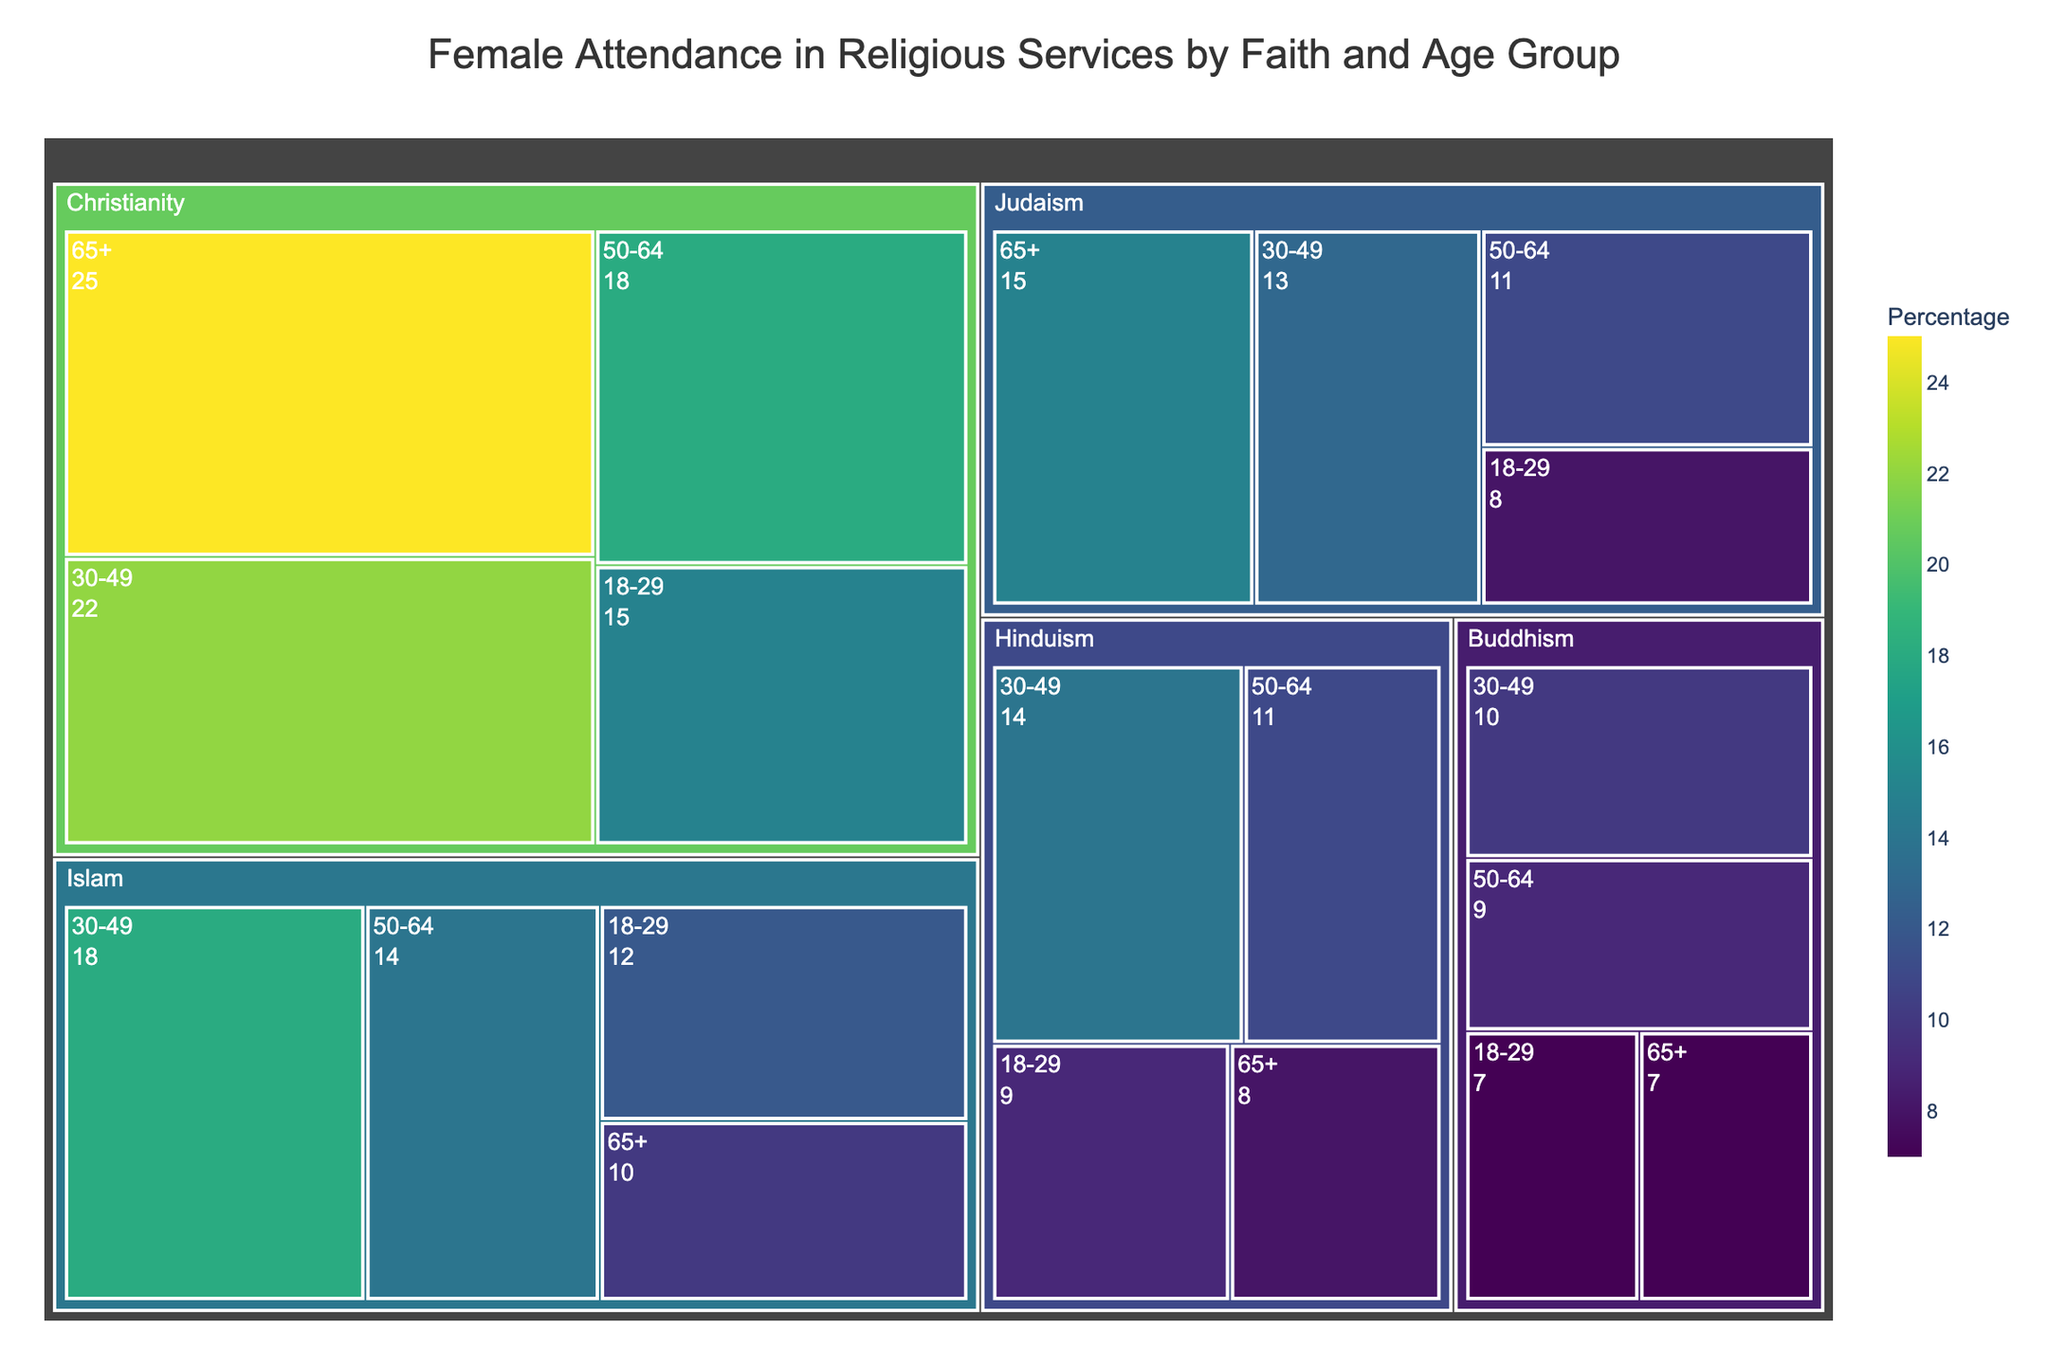What is the title of the treemap? The title is displayed at the top center of the treemap, showing the main subject of the visualization.
Answer: Female Attendance in Religious Services by Faith and Age Group Which age group in Christianity has the highest percentage of attendance? The treemap divides the data into different age groups under each faith, and the largest value under Christianity can be identified from those groups.
Answer: 65+ How does female attendance compare between the 18-29 age group in Christianity and Islam? By observing the treemap, we locate the 18-29 age group under both Christianity and Islam and compare their values.
Answer: Christianity: 15%, Islam: 12% What is the total percentage of female attendance in the 30-49 age group across all faiths? Sum the percentages of the 30-49 age group for Christianity, Islam, Judaism, Hinduism, and Buddhism, as listed on the treemap: 22+18+13+14+10.
Answer: 77% Which faith has the lowest percentage of female attendance in the 65+ age group? We check the treemap for the 65+ age group under each faith and identify the smallest value.
Answer: Buddhism What is the difference in female attendance between the 50-64 age group in Judaism and Islam? Locate the values for the 50-64 age group in both Judaism and Islam and subtract the smaller from the larger: 14 - 11.
Answer: 3% How many distinct age groups are represented in the treemap? The treemap visually indicates distinct age categories under each faith.
Answer: 4 Which age group has the smallest variance in female attendance across all faiths? Calculate the variance for each age group's percentages across the faiths and identify the smallest one.
Answer: 65+ In which faith do we see the greatest drop in attendance percentage between the 30-49 and 50-64 age groups? Compare the values for these two age groups within each faith and determine the one with the largest decrease.
Answer: Islam How does the color intensity relate to the percentages in the treemap? The treemap uses a continuous color scale where higher percentages are represented by more intense colors.
Answer: Higher percentages are shown with more intense colors 